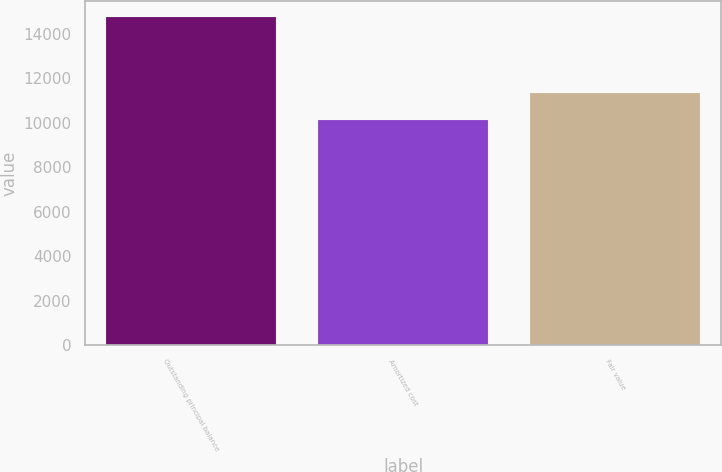<chart> <loc_0><loc_0><loc_500><loc_500><bar_chart><fcel>Outstanding principal balance<fcel>Amortized cost<fcel>Fair value<nl><fcel>14741<fcel>10110<fcel>11338<nl></chart> 